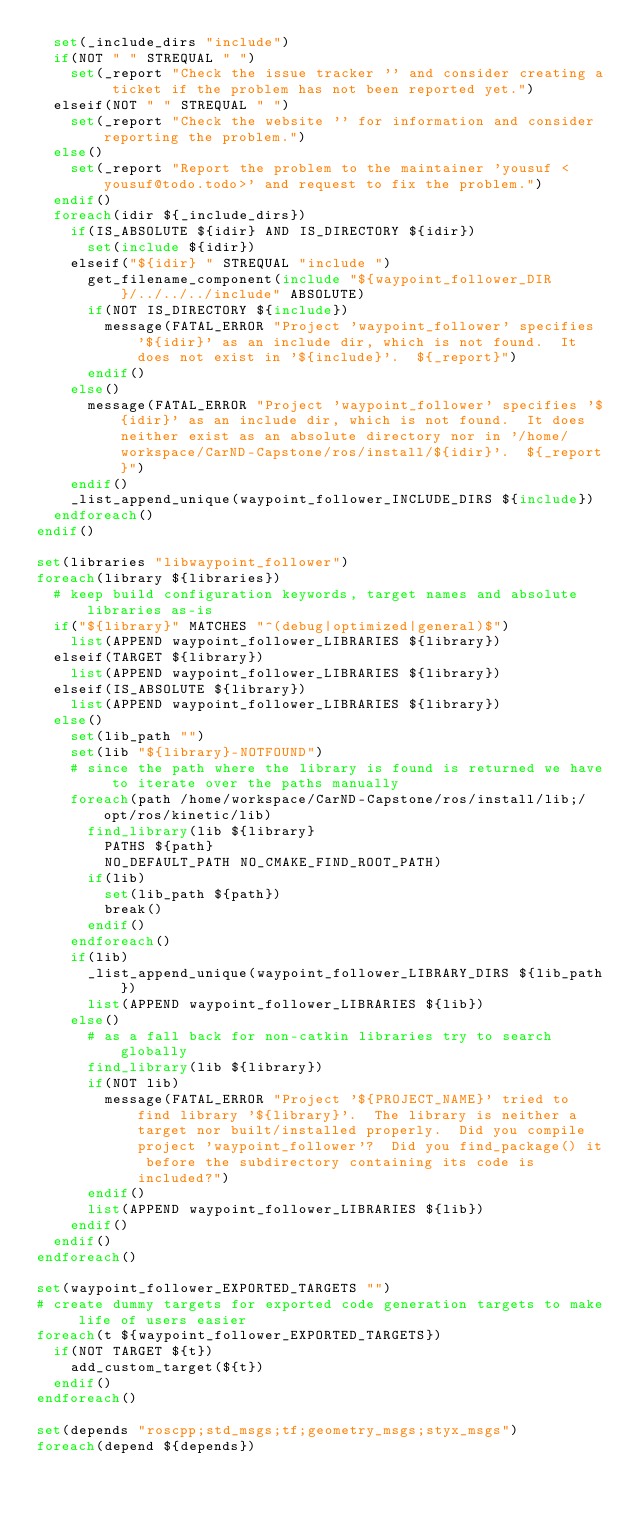Convert code to text. <code><loc_0><loc_0><loc_500><loc_500><_CMake_>  set(_include_dirs "include")
  if(NOT " " STREQUAL " ")
    set(_report "Check the issue tracker '' and consider creating a ticket if the problem has not been reported yet.")
  elseif(NOT " " STREQUAL " ")
    set(_report "Check the website '' for information and consider reporting the problem.")
  else()
    set(_report "Report the problem to the maintainer 'yousuf <yousuf@todo.todo>' and request to fix the problem.")
  endif()
  foreach(idir ${_include_dirs})
    if(IS_ABSOLUTE ${idir} AND IS_DIRECTORY ${idir})
      set(include ${idir})
    elseif("${idir} " STREQUAL "include ")
      get_filename_component(include "${waypoint_follower_DIR}/../../../include" ABSOLUTE)
      if(NOT IS_DIRECTORY ${include})
        message(FATAL_ERROR "Project 'waypoint_follower' specifies '${idir}' as an include dir, which is not found.  It does not exist in '${include}'.  ${_report}")
      endif()
    else()
      message(FATAL_ERROR "Project 'waypoint_follower' specifies '${idir}' as an include dir, which is not found.  It does neither exist as an absolute directory nor in '/home/workspace/CarND-Capstone/ros/install/${idir}'.  ${_report}")
    endif()
    _list_append_unique(waypoint_follower_INCLUDE_DIRS ${include})
  endforeach()
endif()

set(libraries "libwaypoint_follower")
foreach(library ${libraries})
  # keep build configuration keywords, target names and absolute libraries as-is
  if("${library}" MATCHES "^(debug|optimized|general)$")
    list(APPEND waypoint_follower_LIBRARIES ${library})
  elseif(TARGET ${library})
    list(APPEND waypoint_follower_LIBRARIES ${library})
  elseif(IS_ABSOLUTE ${library})
    list(APPEND waypoint_follower_LIBRARIES ${library})
  else()
    set(lib_path "")
    set(lib "${library}-NOTFOUND")
    # since the path where the library is found is returned we have to iterate over the paths manually
    foreach(path /home/workspace/CarND-Capstone/ros/install/lib;/opt/ros/kinetic/lib)
      find_library(lib ${library}
        PATHS ${path}
        NO_DEFAULT_PATH NO_CMAKE_FIND_ROOT_PATH)
      if(lib)
        set(lib_path ${path})
        break()
      endif()
    endforeach()
    if(lib)
      _list_append_unique(waypoint_follower_LIBRARY_DIRS ${lib_path})
      list(APPEND waypoint_follower_LIBRARIES ${lib})
    else()
      # as a fall back for non-catkin libraries try to search globally
      find_library(lib ${library})
      if(NOT lib)
        message(FATAL_ERROR "Project '${PROJECT_NAME}' tried to find library '${library}'.  The library is neither a target nor built/installed properly.  Did you compile project 'waypoint_follower'?  Did you find_package() it before the subdirectory containing its code is included?")
      endif()
      list(APPEND waypoint_follower_LIBRARIES ${lib})
    endif()
  endif()
endforeach()

set(waypoint_follower_EXPORTED_TARGETS "")
# create dummy targets for exported code generation targets to make life of users easier
foreach(t ${waypoint_follower_EXPORTED_TARGETS})
  if(NOT TARGET ${t})
    add_custom_target(${t})
  endif()
endforeach()

set(depends "roscpp;std_msgs;tf;geometry_msgs;styx_msgs")
foreach(depend ${depends})</code> 